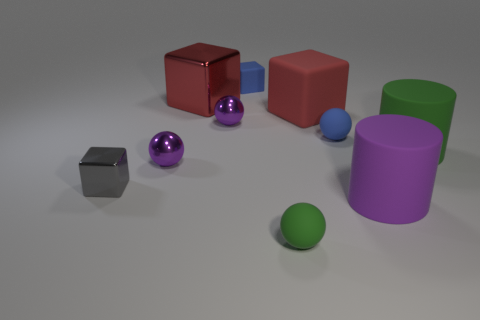Are there any other things that are the same color as the big rubber cube?
Give a very brief answer. Yes. Do the large metallic thing and the large matte cube have the same color?
Offer a very short reply. Yes. Does the rubber cube in front of the tiny blue matte cube have the same color as the large metallic object?
Provide a succinct answer. Yes. There is a metallic thing behind the red matte thing; does it have the same color as the cube right of the small rubber cube?
Offer a very short reply. Yes. Is the number of large green rubber cylinders greater than the number of small green rubber cubes?
Your answer should be compact. Yes. How many objects are the same color as the tiny matte block?
Your answer should be very brief. 1. What is the color of the other large object that is the same shape as the big metal thing?
Keep it short and to the point. Red. What is the purple object that is in front of the big green rubber thing and left of the purple rubber thing made of?
Provide a short and direct response. Metal. Does the purple object that is on the right side of the tiny blue rubber ball have the same material as the green thing on the right side of the purple matte object?
Your answer should be compact. Yes. What is the size of the purple cylinder?
Offer a terse response. Large. 